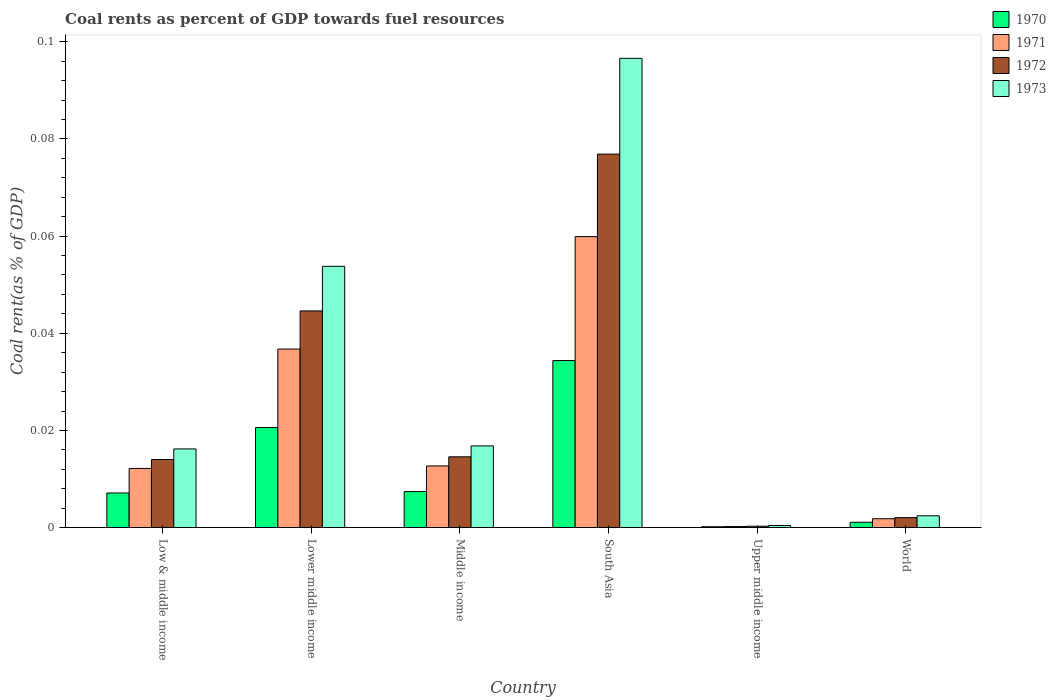How many different coloured bars are there?
Ensure brevity in your answer.  4. How many groups of bars are there?
Provide a short and direct response. 6. How many bars are there on the 3rd tick from the right?
Give a very brief answer. 4. In how many cases, is the number of bars for a given country not equal to the number of legend labels?
Your answer should be very brief. 0. What is the coal rent in 1971 in Lower middle income?
Your response must be concise. 0.04. Across all countries, what is the maximum coal rent in 1972?
Make the answer very short. 0.08. Across all countries, what is the minimum coal rent in 1971?
Your answer should be compact. 0. In which country was the coal rent in 1972 maximum?
Offer a very short reply. South Asia. In which country was the coal rent in 1973 minimum?
Provide a short and direct response. Upper middle income. What is the total coal rent in 1971 in the graph?
Ensure brevity in your answer.  0.12. What is the difference between the coal rent in 1971 in Lower middle income and that in South Asia?
Give a very brief answer. -0.02. What is the difference between the coal rent in 1971 in Low & middle income and the coal rent in 1970 in South Asia?
Your answer should be very brief. -0.02. What is the average coal rent in 1972 per country?
Your response must be concise. 0.03. What is the difference between the coal rent of/in 1972 and coal rent of/in 1971 in Low & middle income?
Make the answer very short. 0. In how many countries, is the coal rent in 1973 greater than 0.088 %?
Offer a very short reply. 1. What is the ratio of the coal rent in 1970 in Low & middle income to that in Lower middle income?
Ensure brevity in your answer.  0.35. Is the difference between the coal rent in 1972 in Lower middle income and South Asia greater than the difference between the coal rent in 1971 in Lower middle income and South Asia?
Ensure brevity in your answer.  No. What is the difference between the highest and the second highest coal rent in 1972?
Provide a short and direct response. 0.03. What is the difference between the highest and the lowest coal rent in 1972?
Your answer should be very brief. 0.08. In how many countries, is the coal rent in 1971 greater than the average coal rent in 1971 taken over all countries?
Your answer should be compact. 2. Is the sum of the coal rent in 1972 in Low & middle income and Upper middle income greater than the maximum coal rent in 1971 across all countries?
Provide a short and direct response. No. Is it the case that in every country, the sum of the coal rent in 1970 and coal rent in 1973 is greater than the sum of coal rent in 1972 and coal rent in 1971?
Offer a very short reply. No. What does the 1st bar from the right in Lower middle income represents?
Keep it short and to the point. 1973. How many bars are there?
Ensure brevity in your answer.  24. Does the graph contain any zero values?
Provide a short and direct response. No. Does the graph contain grids?
Make the answer very short. No. Where does the legend appear in the graph?
Offer a terse response. Top right. How many legend labels are there?
Your answer should be compact. 4. How are the legend labels stacked?
Provide a succinct answer. Vertical. What is the title of the graph?
Provide a succinct answer. Coal rents as percent of GDP towards fuel resources. What is the label or title of the Y-axis?
Offer a terse response. Coal rent(as % of GDP). What is the Coal rent(as % of GDP) in 1970 in Low & middle income?
Ensure brevity in your answer.  0.01. What is the Coal rent(as % of GDP) in 1971 in Low & middle income?
Provide a succinct answer. 0.01. What is the Coal rent(as % of GDP) in 1972 in Low & middle income?
Offer a terse response. 0.01. What is the Coal rent(as % of GDP) of 1973 in Low & middle income?
Your answer should be compact. 0.02. What is the Coal rent(as % of GDP) in 1970 in Lower middle income?
Your answer should be compact. 0.02. What is the Coal rent(as % of GDP) in 1971 in Lower middle income?
Your answer should be compact. 0.04. What is the Coal rent(as % of GDP) in 1972 in Lower middle income?
Provide a succinct answer. 0.04. What is the Coal rent(as % of GDP) of 1973 in Lower middle income?
Provide a succinct answer. 0.05. What is the Coal rent(as % of GDP) of 1970 in Middle income?
Offer a very short reply. 0.01. What is the Coal rent(as % of GDP) of 1971 in Middle income?
Give a very brief answer. 0.01. What is the Coal rent(as % of GDP) of 1972 in Middle income?
Offer a terse response. 0.01. What is the Coal rent(as % of GDP) of 1973 in Middle income?
Give a very brief answer. 0.02. What is the Coal rent(as % of GDP) in 1970 in South Asia?
Give a very brief answer. 0.03. What is the Coal rent(as % of GDP) of 1971 in South Asia?
Give a very brief answer. 0.06. What is the Coal rent(as % of GDP) of 1972 in South Asia?
Your answer should be compact. 0.08. What is the Coal rent(as % of GDP) in 1973 in South Asia?
Provide a succinct answer. 0.1. What is the Coal rent(as % of GDP) of 1970 in Upper middle income?
Offer a terse response. 0. What is the Coal rent(as % of GDP) of 1971 in Upper middle income?
Your response must be concise. 0. What is the Coal rent(as % of GDP) of 1972 in Upper middle income?
Make the answer very short. 0. What is the Coal rent(as % of GDP) in 1973 in Upper middle income?
Make the answer very short. 0. What is the Coal rent(as % of GDP) in 1970 in World?
Offer a very short reply. 0. What is the Coal rent(as % of GDP) of 1971 in World?
Your answer should be very brief. 0. What is the Coal rent(as % of GDP) in 1972 in World?
Offer a terse response. 0. What is the Coal rent(as % of GDP) in 1973 in World?
Your answer should be compact. 0. Across all countries, what is the maximum Coal rent(as % of GDP) in 1970?
Your answer should be compact. 0.03. Across all countries, what is the maximum Coal rent(as % of GDP) in 1971?
Give a very brief answer. 0.06. Across all countries, what is the maximum Coal rent(as % of GDP) in 1972?
Offer a very short reply. 0.08. Across all countries, what is the maximum Coal rent(as % of GDP) in 1973?
Offer a very short reply. 0.1. Across all countries, what is the minimum Coal rent(as % of GDP) in 1970?
Give a very brief answer. 0. Across all countries, what is the minimum Coal rent(as % of GDP) of 1971?
Provide a short and direct response. 0. Across all countries, what is the minimum Coal rent(as % of GDP) in 1972?
Ensure brevity in your answer.  0. Across all countries, what is the minimum Coal rent(as % of GDP) of 1973?
Provide a succinct answer. 0. What is the total Coal rent(as % of GDP) in 1970 in the graph?
Provide a short and direct response. 0.07. What is the total Coal rent(as % of GDP) of 1971 in the graph?
Offer a terse response. 0.12. What is the total Coal rent(as % of GDP) of 1972 in the graph?
Keep it short and to the point. 0.15. What is the total Coal rent(as % of GDP) of 1973 in the graph?
Your response must be concise. 0.19. What is the difference between the Coal rent(as % of GDP) of 1970 in Low & middle income and that in Lower middle income?
Provide a succinct answer. -0.01. What is the difference between the Coal rent(as % of GDP) in 1971 in Low & middle income and that in Lower middle income?
Your response must be concise. -0.02. What is the difference between the Coal rent(as % of GDP) in 1972 in Low & middle income and that in Lower middle income?
Keep it short and to the point. -0.03. What is the difference between the Coal rent(as % of GDP) in 1973 in Low & middle income and that in Lower middle income?
Make the answer very short. -0.04. What is the difference between the Coal rent(as % of GDP) in 1970 in Low & middle income and that in Middle income?
Your answer should be compact. -0. What is the difference between the Coal rent(as % of GDP) in 1971 in Low & middle income and that in Middle income?
Ensure brevity in your answer.  -0. What is the difference between the Coal rent(as % of GDP) of 1972 in Low & middle income and that in Middle income?
Ensure brevity in your answer.  -0. What is the difference between the Coal rent(as % of GDP) in 1973 in Low & middle income and that in Middle income?
Provide a short and direct response. -0. What is the difference between the Coal rent(as % of GDP) of 1970 in Low & middle income and that in South Asia?
Your answer should be compact. -0.03. What is the difference between the Coal rent(as % of GDP) in 1971 in Low & middle income and that in South Asia?
Keep it short and to the point. -0.05. What is the difference between the Coal rent(as % of GDP) of 1972 in Low & middle income and that in South Asia?
Keep it short and to the point. -0.06. What is the difference between the Coal rent(as % of GDP) in 1973 in Low & middle income and that in South Asia?
Your answer should be very brief. -0.08. What is the difference between the Coal rent(as % of GDP) of 1970 in Low & middle income and that in Upper middle income?
Make the answer very short. 0.01. What is the difference between the Coal rent(as % of GDP) in 1971 in Low & middle income and that in Upper middle income?
Make the answer very short. 0.01. What is the difference between the Coal rent(as % of GDP) of 1972 in Low & middle income and that in Upper middle income?
Offer a very short reply. 0.01. What is the difference between the Coal rent(as % of GDP) in 1973 in Low & middle income and that in Upper middle income?
Offer a terse response. 0.02. What is the difference between the Coal rent(as % of GDP) in 1970 in Low & middle income and that in World?
Ensure brevity in your answer.  0.01. What is the difference between the Coal rent(as % of GDP) in 1971 in Low & middle income and that in World?
Provide a succinct answer. 0.01. What is the difference between the Coal rent(as % of GDP) in 1972 in Low & middle income and that in World?
Your answer should be compact. 0.01. What is the difference between the Coal rent(as % of GDP) of 1973 in Low & middle income and that in World?
Keep it short and to the point. 0.01. What is the difference between the Coal rent(as % of GDP) of 1970 in Lower middle income and that in Middle income?
Offer a terse response. 0.01. What is the difference between the Coal rent(as % of GDP) in 1971 in Lower middle income and that in Middle income?
Your answer should be compact. 0.02. What is the difference between the Coal rent(as % of GDP) in 1973 in Lower middle income and that in Middle income?
Offer a terse response. 0.04. What is the difference between the Coal rent(as % of GDP) in 1970 in Lower middle income and that in South Asia?
Keep it short and to the point. -0.01. What is the difference between the Coal rent(as % of GDP) in 1971 in Lower middle income and that in South Asia?
Offer a terse response. -0.02. What is the difference between the Coal rent(as % of GDP) of 1972 in Lower middle income and that in South Asia?
Give a very brief answer. -0.03. What is the difference between the Coal rent(as % of GDP) in 1973 in Lower middle income and that in South Asia?
Make the answer very short. -0.04. What is the difference between the Coal rent(as % of GDP) of 1970 in Lower middle income and that in Upper middle income?
Keep it short and to the point. 0.02. What is the difference between the Coal rent(as % of GDP) in 1971 in Lower middle income and that in Upper middle income?
Provide a succinct answer. 0.04. What is the difference between the Coal rent(as % of GDP) of 1972 in Lower middle income and that in Upper middle income?
Offer a very short reply. 0.04. What is the difference between the Coal rent(as % of GDP) in 1973 in Lower middle income and that in Upper middle income?
Ensure brevity in your answer.  0.05. What is the difference between the Coal rent(as % of GDP) in 1970 in Lower middle income and that in World?
Your response must be concise. 0.02. What is the difference between the Coal rent(as % of GDP) in 1971 in Lower middle income and that in World?
Provide a succinct answer. 0.03. What is the difference between the Coal rent(as % of GDP) in 1972 in Lower middle income and that in World?
Make the answer very short. 0.04. What is the difference between the Coal rent(as % of GDP) of 1973 in Lower middle income and that in World?
Offer a very short reply. 0.05. What is the difference between the Coal rent(as % of GDP) of 1970 in Middle income and that in South Asia?
Your answer should be compact. -0.03. What is the difference between the Coal rent(as % of GDP) in 1971 in Middle income and that in South Asia?
Make the answer very short. -0.05. What is the difference between the Coal rent(as % of GDP) of 1972 in Middle income and that in South Asia?
Your answer should be very brief. -0.06. What is the difference between the Coal rent(as % of GDP) of 1973 in Middle income and that in South Asia?
Your response must be concise. -0.08. What is the difference between the Coal rent(as % of GDP) of 1970 in Middle income and that in Upper middle income?
Keep it short and to the point. 0.01. What is the difference between the Coal rent(as % of GDP) of 1971 in Middle income and that in Upper middle income?
Give a very brief answer. 0.01. What is the difference between the Coal rent(as % of GDP) of 1972 in Middle income and that in Upper middle income?
Provide a short and direct response. 0.01. What is the difference between the Coal rent(as % of GDP) of 1973 in Middle income and that in Upper middle income?
Give a very brief answer. 0.02. What is the difference between the Coal rent(as % of GDP) in 1970 in Middle income and that in World?
Give a very brief answer. 0.01. What is the difference between the Coal rent(as % of GDP) in 1971 in Middle income and that in World?
Your answer should be very brief. 0.01. What is the difference between the Coal rent(as % of GDP) in 1972 in Middle income and that in World?
Your answer should be compact. 0.01. What is the difference between the Coal rent(as % of GDP) of 1973 in Middle income and that in World?
Your answer should be very brief. 0.01. What is the difference between the Coal rent(as % of GDP) in 1970 in South Asia and that in Upper middle income?
Make the answer very short. 0.03. What is the difference between the Coal rent(as % of GDP) of 1971 in South Asia and that in Upper middle income?
Keep it short and to the point. 0.06. What is the difference between the Coal rent(as % of GDP) of 1972 in South Asia and that in Upper middle income?
Keep it short and to the point. 0.08. What is the difference between the Coal rent(as % of GDP) in 1973 in South Asia and that in Upper middle income?
Your answer should be compact. 0.1. What is the difference between the Coal rent(as % of GDP) of 1970 in South Asia and that in World?
Ensure brevity in your answer.  0.03. What is the difference between the Coal rent(as % of GDP) of 1971 in South Asia and that in World?
Your answer should be very brief. 0.06. What is the difference between the Coal rent(as % of GDP) of 1972 in South Asia and that in World?
Your response must be concise. 0.07. What is the difference between the Coal rent(as % of GDP) of 1973 in South Asia and that in World?
Offer a very short reply. 0.09. What is the difference between the Coal rent(as % of GDP) of 1970 in Upper middle income and that in World?
Ensure brevity in your answer.  -0. What is the difference between the Coal rent(as % of GDP) of 1971 in Upper middle income and that in World?
Ensure brevity in your answer.  -0. What is the difference between the Coal rent(as % of GDP) in 1972 in Upper middle income and that in World?
Provide a succinct answer. -0. What is the difference between the Coal rent(as % of GDP) in 1973 in Upper middle income and that in World?
Provide a succinct answer. -0. What is the difference between the Coal rent(as % of GDP) in 1970 in Low & middle income and the Coal rent(as % of GDP) in 1971 in Lower middle income?
Your response must be concise. -0.03. What is the difference between the Coal rent(as % of GDP) of 1970 in Low & middle income and the Coal rent(as % of GDP) of 1972 in Lower middle income?
Offer a very short reply. -0.04. What is the difference between the Coal rent(as % of GDP) of 1970 in Low & middle income and the Coal rent(as % of GDP) of 1973 in Lower middle income?
Your answer should be very brief. -0.05. What is the difference between the Coal rent(as % of GDP) in 1971 in Low & middle income and the Coal rent(as % of GDP) in 1972 in Lower middle income?
Keep it short and to the point. -0.03. What is the difference between the Coal rent(as % of GDP) in 1971 in Low & middle income and the Coal rent(as % of GDP) in 1973 in Lower middle income?
Make the answer very short. -0.04. What is the difference between the Coal rent(as % of GDP) in 1972 in Low & middle income and the Coal rent(as % of GDP) in 1973 in Lower middle income?
Your answer should be compact. -0.04. What is the difference between the Coal rent(as % of GDP) in 1970 in Low & middle income and the Coal rent(as % of GDP) in 1971 in Middle income?
Make the answer very short. -0.01. What is the difference between the Coal rent(as % of GDP) in 1970 in Low & middle income and the Coal rent(as % of GDP) in 1972 in Middle income?
Offer a very short reply. -0.01. What is the difference between the Coal rent(as % of GDP) of 1970 in Low & middle income and the Coal rent(as % of GDP) of 1973 in Middle income?
Offer a terse response. -0.01. What is the difference between the Coal rent(as % of GDP) of 1971 in Low & middle income and the Coal rent(as % of GDP) of 1972 in Middle income?
Provide a short and direct response. -0. What is the difference between the Coal rent(as % of GDP) in 1971 in Low & middle income and the Coal rent(as % of GDP) in 1973 in Middle income?
Keep it short and to the point. -0. What is the difference between the Coal rent(as % of GDP) in 1972 in Low & middle income and the Coal rent(as % of GDP) in 1973 in Middle income?
Keep it short and to the point. -0. What is the difference between the Coal rent(as % of GDP) of 1970 in Low & middle income and the Coal rent(as % of GDP) of 1971 in South Asia?
Provide a succinct answer. -0.05. What is the difference between the Coal rent(as % of GDP) of 1970 in Low & middle income and the Coal rent(as % of GDP) of 1972 in South Asia?
Offer a very short reply. -0.07. What is the difference between the Coal rent(as % of GDP) in 1970 in Low & middle income and the Coal rent(as % of GDP) in 1973 in South Asia?
Keep it short and to the point. -0.09. What is the difference between the Coal rent(as % of GDP) of 1971 in Low & middle income and the Coal rent(as % of GDP) of 1972 in South Asia?
Offer a terse response. -0.06. What is the difference between the Coal rent(as % of GDP) of 1971 in Low & middle income and the Coal rent(as % of GDP) of 1973 in South Asia?
Make the answer very short. -0.08. What is the difference between the Coal rent(as % of GDP) in 1972 in Low & middle income and the Coal rent(as % of GDP) in 1973 in South Asia?
Your response must be concise. -0.08. What is the difference between the Coal rent(as % of GDP) of 1970 in Low & middle income and the Coal rent(as % of GDP) of 1971 in Upper middle income?
Ensure brevity in your answer.  0.01. What is the difference between the Coal rent(as % of GDP) of 1970 in Low & middle income and the Coal rent(as % of GDP) of 1972 in Upper middle income?
Provide a short and direct response. 0.01. What is the difference between the Coal rent(as % of GDP) of 1970 in Low & middle income and the Coal rent(as % of GDP) of 1973 in Upper middle income?
Ensure brevity in your answer.  0.01. What is the difference between the Coal rent(as % of GDP) of 1971 in Low & middle income and the Coal rent(as % of GDP) of 1972 in Upper middle income?
Provide a succinct answer. 0.01. What is the difference between the Coal rent(as % of GDP) in 1971 in Low & middle income and the Coal rent(as % of GDP) in 1973 in Upper middle income?
Ensure brevity in your answer.  0.01. What is the difference between the Coal rent(as % of GDP) of 1972 in Low & middle income and the Coal rent(as % of GDP) of 1973 in Upper middle income?
Make the answer very short. 0.01. What is the difference between the Coal rent(as % of GDP) of 1970 in Low & middle income and the Coal rent(as % of GDP) of 1971 in World?
Give a very brief answer. 0.01. What is the difference between the Coal rent(as % of GDP) in 1970 in Low & middle income and the Coal rent(as % of GDP) in 1972 in World?
Offer a very short reply. 0.01. What is the difference between the Coal rent(as % of GDP) in 1970 in Low & middle income and the Coal rent(as % of GDP) in 1973 in World?
Make the answer very short. 0. What is the difference between the Coal rent(as % of GDP) of 1971 in Low & middle income and the Coal rent(as % of GDP) of 1972 in World?
Provide a short and direct response. 0.01. What is the difference between the Coal rent(as % of GDP) of 1971 in Low & middle income and the Coal rent(as % of GDP) of 1973 in World?
Provide a short and direct response. 0.01. What is the difference between the Coal rent(as % of GDP) in 1972 in Low & middle income and the Coal rent(as % of GDP) in 1973 in World?
Your response must be concise. 0.01. What is the difference between the Coal rent(as % of GDP) in 1970 in Lower middle income and the Coal rent(as % of GDP) in 1971 in Middle income?
Give a very brief answer. 0.01. What is the difference between the Coal rent(as % of GDP) in 1970 in Lower middle income and the Coal rent(as % of GDP) in 1972 in Middle income?
Offer a very short reply. 0.01. What is the difference between the Coal rent(as % of GDP) in 1970 in Lower middle income and the Coal rent(as % of GDP) in 1973 in Middle income?
Your response must be concise. 0. What is the difference between the Coal rent(as % of GDP) in 1971 in Lower middle income and the Coal rent(as % of GDP) in 1972 in Middle income?
Your answer should be compact. 0.02. What is the difference between the Coal rent(as % of GDP) in 1971 in Lower middle income and the Coal rent(as % of GDP) in 1973 in Middle income?
Keep it short and to the point. 0.02. What is the difference between the Coal rent(as % of GDP) of 1972 in Lower middle income and the Coal rent(as % of GDP) of 1973 in Middle income?
Ensure brevity in your answer.  0.03. What is the difference between the Coal rent(as % of GDP) in 1970 in Lower middle income and the Coal rent(as % of GDP) in 1971 in South Asia?
Your answer should be very brief. -0.04. What is the difference between the Coal rent(as % of GDP) in 1970 in Lower middle income and the Coal rent(as % of GDP) in 1972 in South Asia?
Make the answer very short. -0.06. What is the difference between the Coal rent(as % of GDP) of 1970 in Lower middle income and the Coal rent(as % of GDP) of 1973 in South Asia?
Keep it short and to the point. -0.08. What is the difference between the Coal rent(as % of GDP) in 1971 in Lower middle income and the Coal rent(as % of GDP) in 1972 in South Asia?
Provide a short and direct response. -0.04. What is the difference between the Coal rent(as % of GDP) of 1971 in Lower middle income and the Coal rent(as % of GDP) of 1973 in South Asia?
Your answer should be very brief. -0.06. What is the difference between the Coal rent(as % of GDP) of 1972 in Lower middle income and the Coal rent(as % of GDP) of 1973 in South Asia?
Offer a terse response. -0.05. What is the difference between the Coal rent(as % of GDP) of 1970 in Lower middle income and the Coal rent(as % of GDP) of 1971 in Upper middle income?
Ensure brevity in your answer.  0.02. What is the difference between the Coal rent(as % of GDP) of 1970 in Lower middle income and the Coal rent(as % of GDP) of 1972 in Upper middle income?
Keep it short and to the point. 0.02. What is the difference between the Coal rent(as % of GDP) of 1970 in Lower middle income and the Coal rent(as % of GDP) of 1973 in Upper middle income?
Ensure brevity in your answer.  0.02. What is the difference between the Coal rent(as % of GDP) of 1971 in Lower middle income and the Coal rent(as % of GDP) of 1972 in Upper middle income?
Provide a succinct answer. 0.04. What is the difference between the Coal rent(as % of GDP) in 1971 in Lower middle income and the Coal rent(as % of GDP) in 1973 in Upper middle income?
Offer a very short reply. 0.04. What is the difference between the Coal rent(as % of GDP) of 1972 in Lower middle income and the Coal rent(as % of GDP) of 1973 in Upper middle income?
Make the answer very short. 0.04. What is the difference between the Coal rent(as % of GDP) of 1970 in Lower middle income and the Coal rent(as % of GDP) of 1971 in World?
Provide a short and direct response. 0.02. What is the difference between the Coal rent(as % of GDP) of 1970 in Lower middle income and the Coal rent(as % of GDP) of 1972 in World?
Make the answer very short. 0.02. What is the difference between the Coal rent(as % of GDP) in 1970 in Lower middle income and the Coal rent(as % of GDP) in 1973 in World?
Keep it short and to the point. 0.02. What is the difference between the Coal rent(as % of GDP) of 1971 in Lower middle income and the Coal rent(as % of GDP) of 1972 in World?
Offer a very short reply. 0.03. What is the difference between the Coal rent(as % of GDP) of 1971 in Lower middle income and the Coal rent(as % of GDP) of 1973 in World?
Provide a succinct answer. 0.03. What is the difference between the Coal rent(as % of GDP) of 1972 in Lower middle income and the Coal rent(as % of GDP) of 1973 in World?
Provide a succinct answer. 0.04. What is the difference between the Coal rent(as % of GDP) of 1970 in Middle income and the Coal rent(as % of GDP) of 1971 in South Asia?
Your answer should be compact. -0.05. What is the difference between the Coal rent(as % of GDP) of 1970 in Middle income and the Coal rent(as % of GDP) of 1972 in South Asia?
Your answer should be compact. -0.07. What is the difference between the Coal rent(as % of GDP) of 1970 in Middle income and the Coal rent(as % of GDP) of 1973 in South Asia?
Make the answer very short. -0.09. What is the difference between the Coal rent(as % of GDP) in 1971 in Middle income and the Coal rent(as % of GDP) in 1972 in South Asia?
Keep it short and to the point. -0.06. What is the difference between the Coal rent(as % of GDP) in 1971 in Middle income and the Coal rent(as % of GDP) in 1973 in South Asia?
Provide a short and direct response. -0.08. What is the difference between the Coal rent(as % of GDP) in 1972 in Middle income and the Coal rent(as % of GDP) in 1973 in South Asia?
Provide a succinct answer. -0.08. What is the difference between the Coal rent(as % of GDP) of 1970 in Middle income and the Coal rent(as % of GDP) of 1971 in Upper middle income?
Ensure brevity in your answer.  0.01. What is the difference between the Coal rent(as % of GDP) in 1970 in Middle income and the Coal rent(as % of GDP) in 1972 in Upper middle income?
Make the answer very short. 0.01. What is the difference between the Coal rent(as % of GDP) in 1970 in Middle income and the Coal rent(as % of GDP) in 1973 in Upper middle income?
Your answer should be compact. 0.01. What is the difference between the Coal rent(as % of GDP) of 1971 in Middle income and the Coal rent(as % of GDP) of 1972 in Upper middle income?
Provide a short and direct response. 0.01. What is the difference between the Coal rent(as % of GDP) of 1971 in Middle income and the Coal rent(as % of GDP) of 1973 in Upper middle income?
Offer a terse response. 0.01. What is the difference between the Coal rent(as % of GDP) in 1972 in Middle income and the Coal rent(as % of GDP) in 1973 in Upper middle income?
Your answer should be compact. 0.01. What is the difference between the Coal rent(as % of GDP) in 1970 in Middle income and the Coal rent(as % of GDP) in 1971 in World?
Your response must be concise. 0.01. What is the difference between the Coal rent(as % of GDP) in 1970 in Middle income and the Coal rent(as % of GDP) in 1972 in World?
Provide a short and direct response. 0.01. What is the difference between the Coal rent(as % of GDP) in 1970 in Middle income and the Coal rent(as % of GDP) in 1973 in World?
Your response must be concise. 0.01. What is the difference between the Coal rent(as % of GDP) in 1971 in Middle income and the Coal rent(as % of GDP) in 1972 in World?
Provide a succinct answer. 0.01. What is the difference between the Coal rent(as % of GDP) in 1971 in Middle income and the Coal rent(as % of GDP) in 1973 in World?
Your answer should be very brief. 0.01. What is the difference between the Coal rent(as % of GDP) in 1972 in Middle income and the Coal rent(as % of GDP) in 1973 in World?
Give a very brief answer. 0.01. What is the difference between the Coal rent(as % of GDP) in 1970 in South Asia and the Coal rent(as % of GDP) in 1971 in Upper middle income?
Provide a succinct answer. 0.03. What is the difference between the Coal rent(as % of GDP) of 1970 in South Asia and the Coal rent(as % of GDP) of 1972 in Upper middle income?
Make the answer very short. 0.03. What is the difference between the Coal rent(as % of GDP) of 1970 in South Asia and the Coal rent(as % of GDP) of 1973 in Upper middle income?
Offer a terse response. 0.03. What is the difference between the Coal rent(as % of GDP) in 1971 in South Asia and the Coal rent(as % of GDP) in 1972 in Upper middle income?
Give a very brief answer. 0.06. What is the difference between the Coal rent(as % of GDP) of 1971 in South Asia and the Coal rent(as % of GDP) of 1973 in Upper middle income?
Your answer should be very brief. 0.06. What is the difference between the Coal rent(as % of GDP) in 1972 in South Asia and the Coal rent(as % of GDP) in 1973 in Upper middle income?
Your answer should be compact. 0.08. What is the difference between the Coal rent(as % of GDP) in 1970 in South Asia and the Coal rent(as % of GDP) in 1971 in World?
Keep it short and to the point. 0.03. What is the difference between the Coal rent(as % of GDP) in 1970 in South Asia and the Coal rent(as % of GDP) in 1972 in World?
Make the answer very short. 0.03. What is the difference between the Coal rent(as % of GDP) in 1970 in South Asia and the Coal rent(as % of GDP) in 1973 in World?
Offer a very short reply. 0.03. What is the difference between the Coal rent(as % of GDP) in 1971 in South Asia and the Coal rent(as % of GDP) in 1972 in World?
Make the answer very short. 0.06. What is the difference between the Coal rent(as % of GDP) of 1971 in South Asia and the Coal rent(as % of GDP) of 1973 in World?
Your answer should be very brief. 0.06. What is the difference between the Coal rent(as % of GDP) of 1972 in South Asia and the Coal rent(as % of GDP) of 1973 in World?
Give a very brief answer. 0.07. What is the difference between the Coal rent(as % of GDP) of 1970 in Upper middle income and the Coal rent(as % of GDP) of 1971 in World?
Ensure brevity in your answer.  -0. What is the difference between the Coal rent(as % of GDP) in 1970 in Upper middle income and the Coal rent(as % of GDP) in 1972 in World?
Ensure brevity in your answer.  -0. What is the difference between the Coal rent(as % of GDP) in 1970 in Upper middle income and the Coal rent(as % of GDP) in 1973 in World?
Keep it short and to the point. -0. What is the difference between the Coal rent(as % of GDP) of 1971 in Upper middle income and the Coal rent(as % of GDP) of 1972 in World?
Offer a very short reply. -0. What is the difference between the Coal rent(as % of GDP) in 1971 in Upper middle income and the Coal rent(as % of GDP) in 1973 in World?
Your answer should be very brief. -0. What is the difference between the Coal rent(as % of GDP) in 1972 in Upper middle income and the Coal rent(as % of GDP) in 1973 in World?
Keep it short and to the point. -0. What is the average Coal rent(as % of GDP) in 1970 per country?
Keep it short and to the point. 0.01. What is the average Coal rent(as % of GDP) of 1971 per country?
Provide a succinct answer. 0.02. What is the average Coal rent(as % of GDP) in 1972 per country?
Your answer should be compact. 0.03. What is the average Coal rent(as % of GDP) of 1973 per country?
Provide a succinct answer. 0.03. What is the difference between the Coal rent(as % of GDP) in 1970 and Coal rent(as % of GDP) in 1971 in Low & middle income?
Offer a very short reply. -0.01. What is the difference between the Coal rent(as % of GDP) in 1970 and Coal rent(as % of GDP) in 1972 in Low & middle income?
Make the answer very short. -0.01. What is the difference between the Coal rent(as % of GDP) of 1970 and Coal rent(as % of GDP) of 1973 in Low & middle income?
Provide a succinct answer. -0.01. What is the difference between the Coal rent(as % of GDP) of 1971 and Coal rent(as % of GDP) of 1972 in Low & middle income?
Offer a terse response. -0. What is the difference between the Coal rent(as % of GDP) of 1971 and Coal rent(as % of GDP) of 1973 in Low & middle income?
Make the answer very short. -0. What is the difference between the Coal rent(as % of GDP) of 1972 and Coal rent(as % of GDP) of 1973 in Low & middle income?
Your answer should be very brief. -0. What is the difference between the Coal rent(as % of GDP) of 1970 and Coal rent(as % of GDP) of 1971 in Lower middle income?
Ensure brevity in your answer.  -0.02. What is the difference between the Coal rent(as % of GDP) in 1970 and Coal rent(as % of GDP) in 1972 in Lower middle income?
Keep it short and to the point. -0.02. What is the difference between the Coal rent(as % of GDP) in 1970 and Coal rent(as % of GDP) in 1973 in Lower middle income?
Your answer should be compact. -0.03. What is the difference between the Coal rent(as % of GDP) of 1971 and Coal rent(as % of GDP) of 1972 in Lower middle income?
Your answer should be compact. -0.01. What is the difference between the Coal rent(as % of GDP) of 1971 and Coal rent(as % of GDP) of 1973 in Lower middle income?
Offer a very short reply. -0.02. What is the difference between the Coal rent(as % of GDP) in 1972 and Coal rent(as % of GDP) in 1973 in Lower middle income?
Give a very brief answer. -0.01. What is the difference between the Coal rent(as % of GDP) in 1970 and Coal rent(as % of GDP) in 1971 in Middle income?
Your answer should be very brief. -0.01. What is the difference between the Coal rent(as % of GDP) in 1970 and Coal rent(as % of GDP) in 1972 in Middle income?
Make the answer very short. -0.01. What is the difference between the Coal rent(as % of GDP) in 1970 and Coal rent(as % of GDP) in 1973 in Middle income?
Ensure brevity in your answer.  -0.01. What is the difference between the Coal rent(as % of GDP) of 1971 and Coal rent(as % of GDP) of 1972 in Middle income?
Offer a very short reply. -0. What is the difference between the Coal rent(as % of GDP) in 1971 and Coal rent(as % of GDP) in 1973 in Middle income?
Offer a very short reply. -0. What is the difference between the Coal rent(as % of GDP) in 1972 and Coal rent(as % of GDP) in 1973 in Middle income?
Offer a very short reply. -0. What is the difference between the Coal rent(as % of GDP) in 1970 and Coal rent(as % of GDP) in 1971 in South Asia?
Offer a very short reply. -0.03. What is the difference between the Coal rent(as % of GDP) of 1970 and Coal rent(as % of GDP) of 1972 in South Asia?
Make the answer very short. -0.04. What is the difference between the Coal rent(as % of GDP) of 1970 and Coal rent(as % of GDP) of 1973 in South Asia?
Your answer should be compact. -0.06. What is the difference between the Coal rent(as % of GDP) in 1971 and Coal rent(as % of GDP) in 1972 in South Asia?
Ensure brevity in your answer.  -0.02. What is the difference between the Coal rent(as % of GDP) of 1971 and Coal rent(as % of GDP) of 1973 in South Asia?
Offer a terse response. -0.04. What is the difference between the Coal rent(as % of GDP) of 1972 and Coal rent(as % of GDP) of 1973 in South Asia?
Offer a terse response. -0.02. What is the difference between the Coal rent(as % of GDP) of 1970 and Coal rent(as % of GDP) of 1971 in Upper middle income?
Your answer should be compact. -0. What is the difference between the Coal rent(as % of GDP) in 1970 and Coal rent(as % of GDP) in 1972 in Upper middle income?
Provide a short and direct response. -0. What is the difference between the Coal rent(as % of GDP) of 1970 and Coal rent(as % of GDP) of 1973 in Upper middle income?
Offer a very short reply. -0. What is the difference between the Coal rent(as % of GDP) in 1971 and Coal rent(as % of GDP) in 1972 in Upper middle income?
Offer a very short reply. -0. What is the difference between the Coal rent(as % of GDP) in 1971 and Coal rent(as % of GDP) in 1973 in Upper middle income?
Keep it short and to the point. -0. What is the difference between the Coal rent(as % of GDP) of 1972 and Coal rent(as % of GDP) of 1973 in Upper middle income?
Provide a short and direct response. -0. What is the difference between the Coal rent(as % of GDP) in 1970 and Coal rent(as % of GDP) in 1971 in World?
Provide a short and direct response. -0. What is the difference between the Coal rent(as % of GDP) of 1970 and Coal rent(as % of GDP) of 1972 in World?
Make the answer very short. -0. What is the difference between the Coal rent(as % of GDP) of 1970 and Coal rent(as % of GDP) of 1973 in World?
Your response must be concise. -0. What is the difference between the Coal rent(as % of GDP) in 1971 and Coal rent(as % of GDP) in 1972 in World?
Make the answer very short. -0. What is the difference between the Coal rent(as % of GDP) in 1971 and Coal rent(as % of GDP) in 1973 in World?
Give a very brief answer. -0. What is the difference between the Coal rent(as % of GDP) of 1972 and Coal rent(as % of GDP) of 1973 in World?
Your response must be concise. -0. What is the ratio of the Coal rent(as % of GDP) of 1970 in Low & middle income to that in Lower middle income?
Make the answer very short. 0.35. What is the ratio of the Coal rent(as % of GDP) in 1971 in Low & middle income to that in Lower middle income?
Provide a succinct answer. 0.33. What is the ratio of the Coal rent(as % of GDP) of 1972 in Low & middle income to that in Lower middle income?
Provide a short and direct response. 0.31. What is the ratio of the Coal rent(as % of GDP) of 1973 in Low & middle income to that in Lower middle income?
Your response must be concise. 0.3. What is the ratio of the Coal rent(as % of GDP) in 1970 in Low & middle income to that in Middle income?
Ensure brevity in your answer.  0.96. What is the ratio of the Coal rent(as % of GDP) of 1971 in Low & middle income to that in Middle income?
Your response must be concise. 0.96. What is the ratio of the Coal rent(as % of GDP) in 1972 in Low & middle income to that in Middle income?
Provide a short and direct response. 0.96. What is the ratio of the Coal rent(as % of GDP) in 1973 in Low & middle income to that in Middle income?
Your answer should be compact. 0.96. What is the ratio of the Coal rent(as % of GDP) in 1970 in Low & middle income to that in South Asia?
Make the answer very short. 0.21. What is the ratio of the Coal rent(as % of GDP) in 1971 in Low & middle income to that in South Asia?
Offer a terse response. 0.2. What is the ratio of the Coal rent(as % of GDP) in 1972 in Low & middle income to that in South Asia?
Ensure brevity in your answer.  0.18. What is the ratio of the Coal rent(as % of GDP) in 1973 in Low & middle income to that in South Asia?
Provide a short and direct response. 0.17. What is the ratio of the Coal rent(as % of GDP) of 1970 in Low & middle income to that in Upper middle income?
Offer a terse response. 38.77. What is the ratio of the Coal rent(as % of GDP) in 1971 in Low & middle income to that in Upper middle income?
Ensure brevity in your answer.  55.66. What is the ratio of the Coal rent(as % of GDP) in 1972 in Low & middle income to that in Upper middle income?
Provide a short and direct response. 49.28. What is the ratio of the Coal rent(as % of GDP) of 1973 in Low & middle income to that in Upper middle income?
Give a very brief answer. 37.59. What is the ratio of the Coal rent(as % of GDP) of 1970 in Low & middle income to that in World?
Keep it short and to the point. 6.48. What is the ratio of the Coal rent(as % of GDP) in 1971 in Low & middle income to that in World?
Offer a very short reply. 6.65. What is the ratio of the Coal rent(as % of GDP) in 1972 in Low & middle income to that in World?
Provide a succinct answer. 6.82. What is the ratio of the Coal rent(as % of GDP) in 1973 in Low & middle income to that in World?
Give a very brief answer. 6.65. What is the ratio of the Coal rent(as % of GDP) in 1970 in Lower middle income to that in Middle income?
Make the answer very short. 2.78. What is the ratio of the Coal rent(as % of GDP) of 1971 in Lower middle income to that in Middle income?
Provide a short and direct response. 2.9. What is the ratio of the Coal rent(as % of GDP) in 1972 in Lower middle income to that in Middle income?
Your response must be concise. 3.06. What is the ratio of the Coal rent(as % of GDP) of 1973 in Lower middle income to that in Middle income?
Give a very brief answer. 3.2. What is the ratio of the Coal rent(as % of GDP) of 1970 in Lower middle income to that in South Asia?
Keep it short and to the point. 0.6. What is the ratio of the Coal rent(as % of GDP) of 1971 in Lower middle income to that in South Asia?
Ensure brevity in your answer.  0.61. What is the ratio of the Coal rent(as % of GDP) of 1972 in Lower middle income to that in South Asia?
Your response must be concise. 0.58. What is the ratio of the Coal rent(as % of GDP) in 1973 in Lower middle income to that in South Asia?
Keep it short and to the point. 0.56. What is the ratio of the Coal rent(as % of GDP) of 1970 in Lower middle income to that in Upper middle income?
Make the answer very short. 112.03. What is the ratio of the Coal rent(as % of GDP) of 1971 in Lower middle income to that in Upper middle income?
Provide a succinct answer. 167.98. What is the ratio of the Coal rent(as % of GDP) of 1972 in Lower middle income to that in Upper middle income?
Your answer should be very brief. 156.82. What is the ratio of the Coal rent(as % of GDP) in 1973 in Lower middle income to that in Upper middle income?
Keep it short and to the point. 124.82. What is the ratio of the Coal rent(as % of GDP) in 1970 in Lower middle income to that in World?
Your answer should be very brief. 18.71. What is the ratio of the Coal rent(as % of GDP) in 1971 in Lower middle income to that in World?
Keep it short and to the point. 20.06. What is the ratio of the Coal rent(as % of GDP) of 1972 in Lower middle income to that in World?
Provide a succinct answer. 21.7. What is the ratio of the Coal rent(as % of GDP) in 1973 in Lower middle income to that in World?
Your response must be concise. 22.07. What is the ratio of the Coal rent(as % of GDP) of 1970 in Middle income to that in South Asia?
Your answer should be compact. 0.22. What is the ratio of the Coal rent(as % of GDP) of 1971 in Middle income to that in South Asia?
Provide a succinct answer. 0.21. What is the ratio of the Coal rent(as % of GDP) of 1972 in Middle income to that in South Asia?
Keep it short and to the point. 0.19. What is the ratio of the Coal rent(as % of GDP) of 1973 in Middle income to that in South Asia?
Your response must be concise. 0.17. What is the ratio of the Coal rent(as % of GDP) in 1970 in Middle income to that in Upper middle income?
Keep it short and to the point. 40.36. What is the ratio of the Coal rent(as % of GDP) of 1971 in Middle income to that in Upper middle income?
Your response must be concise. 58.01. What is the ratio of the Coal rent(as % of GDP) in 1972 in Middle income to that in Upper middle income?
Your answer should be very brief. 51.25. What is the ratio of the Coal rent(as % of GDP) in 1973 in Middle income to that in Upper middle income?
Keep it short and to the point. 39.04. What is the ratio of the Coal rent(as % of GDP) of 1970 in Middle income to that in World?
Provide a succinct answer. 6.74. What is the ratio of the Coal rent(as % of GDP) in 1971 in Middle income to that in World?
Provide a succinct answer. 6.93. What is the ratio of the Coal rent(as % of GDP) of 1972 in Middle income to that in World?
Make the answer very short. 7.09. What is the ratio of the Coal rent(as % of GDP) in 1973 in Middle income to that in World?
Make the answer very short. 6.91. What is the ratio of the Coal rent(as % of GDP) in 1970 in South Asia to that in Upper middle income?
Give a very brief answer. 187.05. What is the ratio of the Coal rent(as % of GDP) of 1971 in South Asia to that in Upper middle income?
Your answer should be very brief. 273.74. What is the ratio of the Coal rent(as % of GDP) of 1972 in South Asia to that in Upper middle income?
Keep it short and to the point. 270.32. What is the ratio of the Coal rent(as % of GDP) in 1973 in South Asia to that in Upper middle income?
Your answer should be very brief. 224.18. What is the ratio of the Coal rent(as % of GDP) of 1970 in South Asia to that in World?
Your response must be concise. 31.24. What is the ratio of the Coal rent(as % of GDP) in 1971 in South Asia to that in World?
Your answer should be compact. 32.69. What is the ratio of the Coal rent(as % of GDP) of 1972 in South Asia to that in World?
Make the answer very short. 37.41. What is the ratio of the Coal rent(as % of GDP) in 1973 in South Asia to that in World?
Offer a terse response. 39.65. What is the ratio of the Coal rent(as % of GDP) in 1970 in Upper middle income to that in World?
Ensure brevity in your answer.  0.17. What is the ratio of the Coal rent(as % of GDP) in 1971 in Upper middle income to that in World?
Offer a terse response. 0.12. What is the ratio of the Coal rent(as % of GDP) in 1972 in Upper middle income to that in World?
Offer a very short reply. 0.14. What is the ratio of the Coal rent(as % of GDP) in 1973 in Upper middle income to that in World?
Provide a succinct answer. 0.18. What is the difference between the highest and the second highest Coal rent(as % of GDP) in 1970?
Your response must be concise. 0.01. What is the difference between the highest and the second highest Coal rent(as % of GDP) of 1971?
Your answer should be very brief. 0.02. What is the difference between the highest and the second highest Coal rent(as % of GDP) of 1972?
Make the answer very short. 0.03. What is the difference between the highest and the second highest Coal rent(as % of GDP) in 1973?
Give a very brief answer. 0.04. What is the difference between the highest and the lowest Coal rent(as % of GDP) of 1970?
Give a very brief answer. 0.03. What is the difference between the highest and the lowest Coal rent(as % of GDP) in 1971?
Provide a succinct answer. 0.06. What is the difference between the highest and the lowest Coal rent(as % of GDP) of 1972?
Provide a succinct answer. 0.08. What is the difference between the highest and the lowest Coal rent(as % of GDP) in 1973?
Your response must be concise. 0.1. 